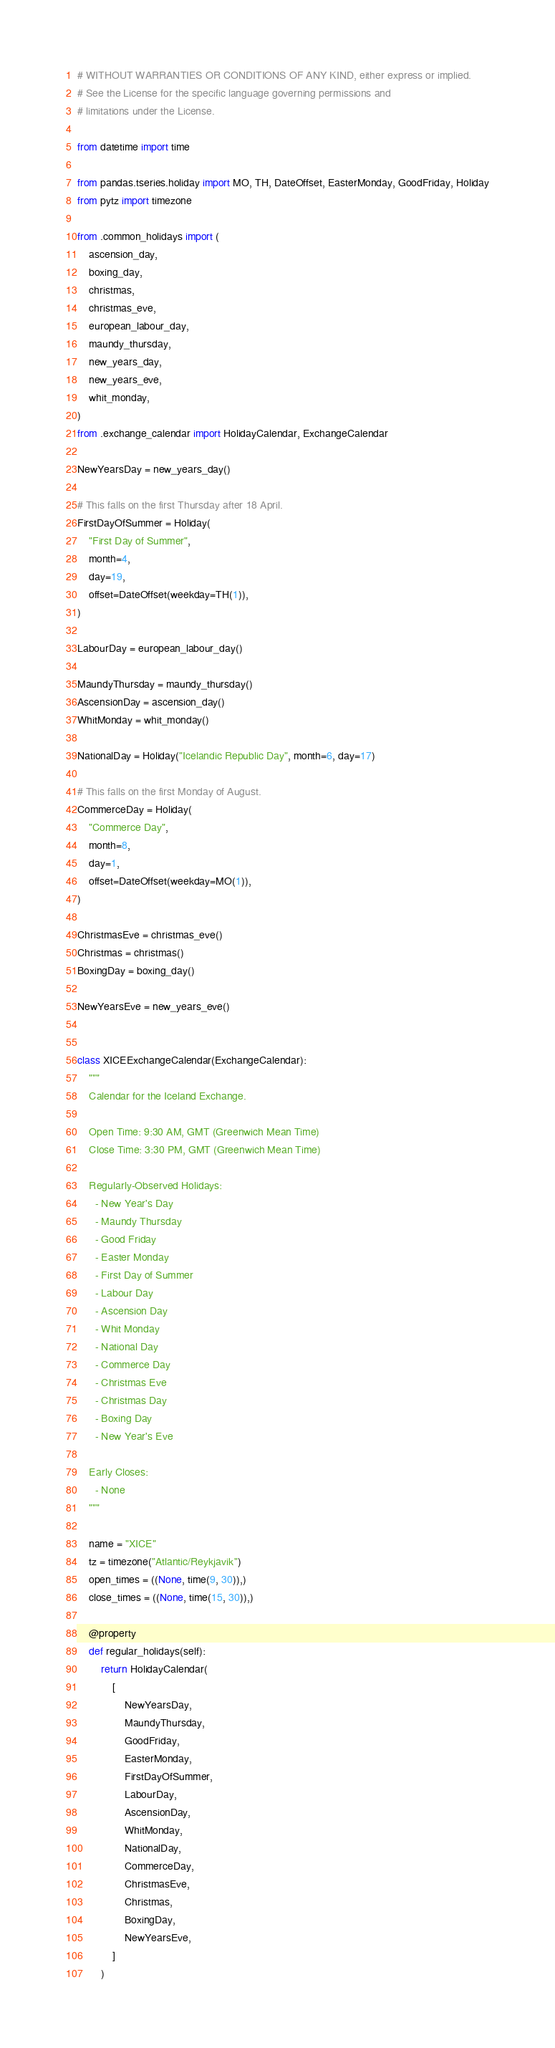Convert code to text. <code><loc_0><loc_0><loc_500><loc_500><_Python_># WITHOUT WARRANTIES OR CONDITIONS OF ANY KIND, either express or implied.
# See the License for the specific language governing permissions and
# limitations under the License.

from datetime import time

from pandas.tseries.holiday import MO, TH, DateOffset, EasterMonday, GoodFriday, Holiday
from pytz import timezone

from .common_holidays import (
    ascension_day,
    boxing_day,
    christmas,
    christmas_eve,
    european_labour_day,
    maundy_thursday,
    new_years_day,
    new_years_eve,
    whit_monday,
)
from .exchange_calendar import HolidayCalendar, ExchangeCalendar

NewYearsDay = new_years_day()

# This falls on the first Thursday after 18 April.
FirstDayOfSummer = Holiday(
    "First Day of Summer",
    month=4,
    day=19,
    offset=DateOffset(weekday=TH(1)),
)

LabourDay = european_labour_day()

MaundyThursday = maundy_thursday()
AscensionDay = ascension_day()
WhitMonday = whit_monday()

NationalDay = Holiday("Icelandic Republic Day", month=6, day=17)

# This falls on the first Monday of August.
CommerceDay = Holiday(
    "Commerce Day",
    month=8,
    day=1,
    offset=DateOffset(weekday=MO(1)),
)

ChristmasEve = christmas_eve()
Christmas = christmas()
BoxingDay = boxing_day()

NewYearsEve = new_years_eve()


class XICEExchangeCalendar(ExchangeCalendar):
    """
    Calendar for the Iceland Exchange.

    Open Time: 9:30 AM, GMT (Greenwich Mean Time)
    Close Time: 3:30 PM, GMT (Greenwich Mean Time)

    Regularly-Observed Holidays:
      - New Year's Day
      - Maundy Thursday
      - Good Friday
      - Easter Monday
      - First Day of Summer
      - Labour Day
      - Ascension Day
      - Whit Monday
      - National Day
      - Commerce Day
      - Christmas Eve
      - Christmas Day
      - Boxing Day
      - New Year's Eve

    Early Closes:
      - None
    """

    name = "XICE"
    tz = timezone("Atlantic/Reykjavik")
    open_times = ((None, time(9, 30)),)
    close_times = ((None, time(15, 30)),)

    @property
    def regular_holidays(self):
        return HolidayCalendar(
            [
                NewYearsDay,
                MaundyThursday,
                GoodFriday,
                EasterMonday,
                FirstDayOfSummer,
                LabourDay,
                AscensionDay,
                WhitMonday,
                NationalDay,
                CommerceDay,
                ChristmasEve,
                Christmas,
                BoxingDay,
                NewYearsEve,
            ]
        )
</code> 